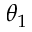Convert formula to latex. <formula><loc_0><loc_0><loc_500><loc_500>\theta _ { 1 }</formula> 